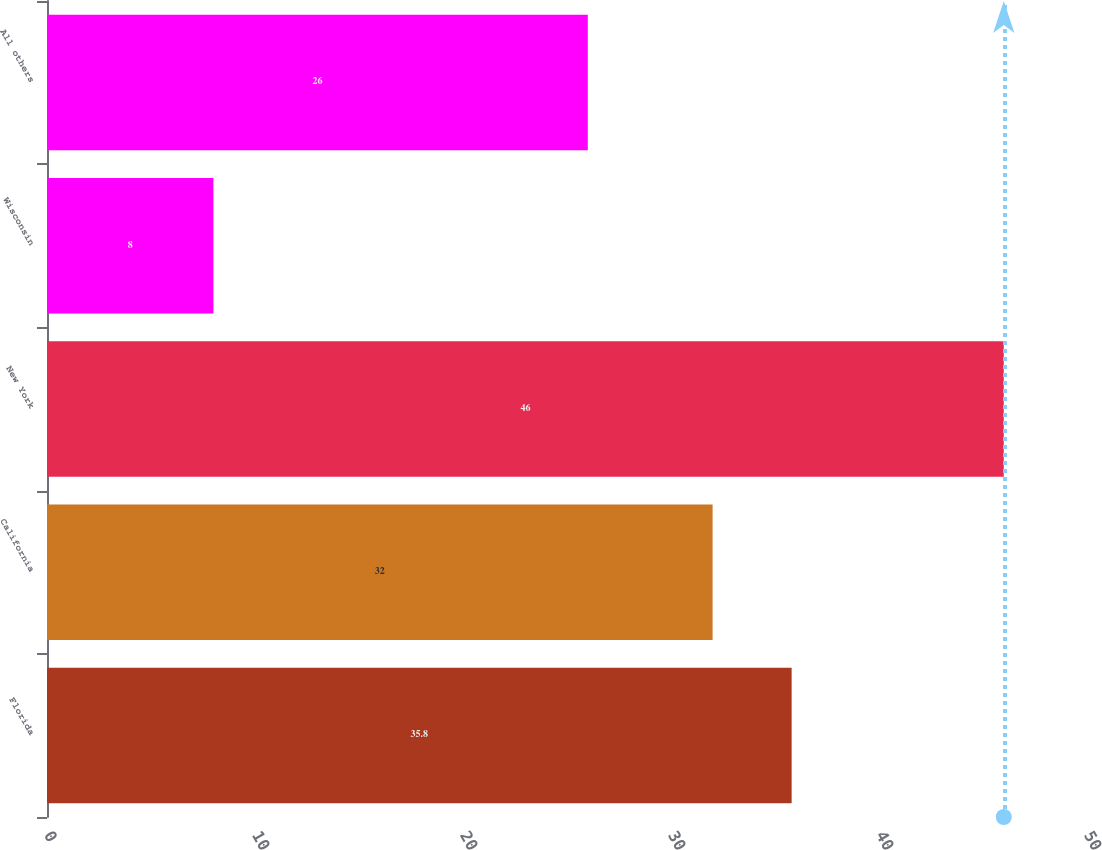Convert chart to OTSL. <chart><loc_0><loc_0><loc_500><loc_500><bar_chart><fcel>Florida<fcel>California<fcel>New York<fcel>Wisconsin<fcel>All others<nl><fcel>35.8<fcel>32<fcel>46<fcel>8<fcel>26<nl></chart> 